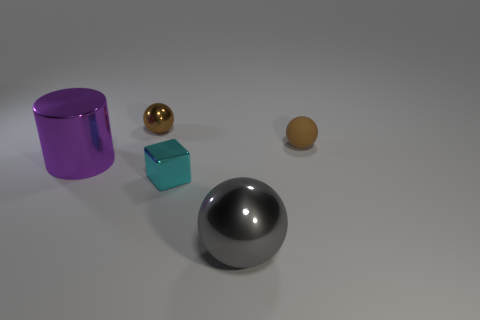Add 1 cyan shiny spheres. How many objects exist? 6 Subtract all tiny brown rubber balls. How many balls are left? 2 Subtract 1 blocks. How many blocks are left? 0 Subtract all cubes. How many objects are left? 4 Subtract all brown blocks. How many cyan balls are left? 0 Subtract all gray balls. How many balls are left? 2 Subtract all big yellow matte objects. Subtract all shiny blocks. How many objects are left? 4 Add 4 purple metallic things. How many purple metallic things are left? 5 Add 2 tiny cyan things. How many tiny cyan things exist? 3 Subtract 0 cyan cylinders. How many objects are left? 5 